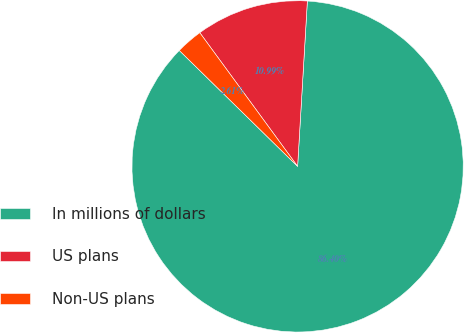Convert chart. <chart><loc_0><loc_0><loc_500><loc_500><pie_chart><fcel>In millions of dollars<fcel>US plans<fcel>Non-US plans<nl><fcel>86.39%<fcel>10.99%<fcel>2.61%<nl></chart> 